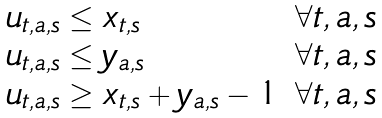<formula> <loc_0><loc_0><loc_500><loc_500>\begin{array} { l l } u _ { t , a , s } \leq x _ { t , s } & \forall t , a , s \\ u _ { t , a , s } \leq y _ { a , s } & \forall t , a , s \\ u _ { t , a , s } \geq x _ { t , s } + y _ { a , s } - 1 & \forall t , a , s \end{array}</formula> 